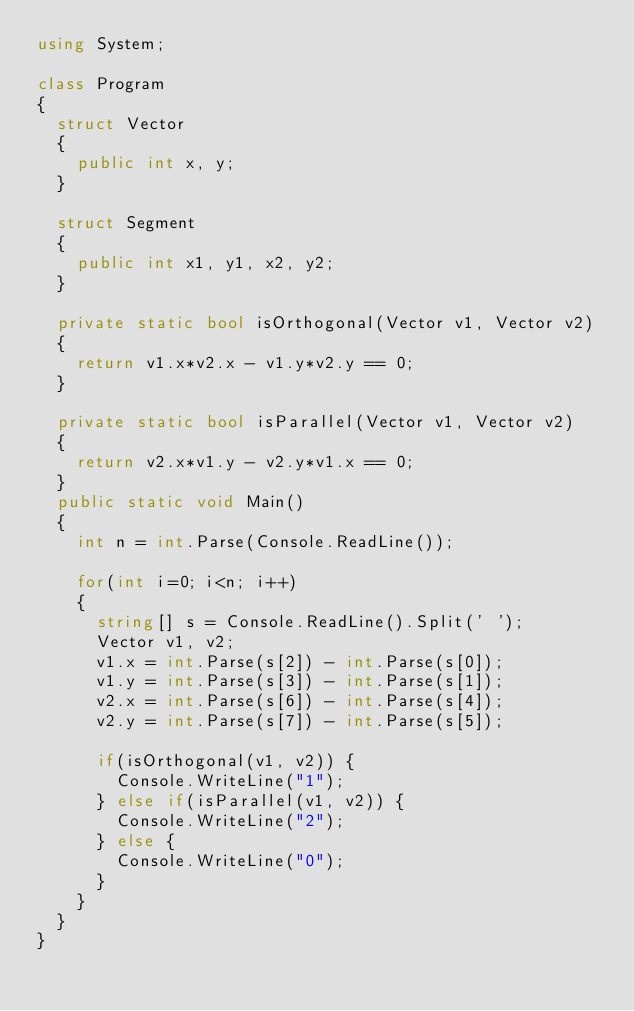<code> <loc_0><loc_0><loc_500><loc_500><_C#_>using System;

class Program
{
  struct Vector
  {
    public int x, y;
  }

  struct Segment
  {
    public int x1, y1, x2, y2;
  }

  private static bool isOrthogonal(Vector v1, Vector v2)
  {
    return v1.x*v2.x - v1.y*v2.y == 0;
  }

  private static bool isParallel(Vector v1, Vector v2)
  {
    return v2.x*v1.y - v2.y*v1.x == 0;
  }
  public static void Main()
  {
    int n = int.Parse(Console.ReadLine());

    for(int i=0; i<n; i++)
    {
      string[] s = Console.ReadLine().Split(' ');
      Vector v1, v2;
      v1.x = int.Parse(s[2]) - int.Parse(s[0]);
      v1.y = int.Parse(s[3]) - int.Parse(s[1]);
      v2.x = int.Parse(s[6]) - int.Parse(s[4]);
      v2.y = int.Parse(s[7]) - int.Parse(s[5]);

      if(isOrthogonal(v1, v2)) {
        Console.WriteLine("1");
      } else if(isParallel(v1, v2)) {
        Console.WriteLine("2");
      } else {
        Console.WriteLine("0");
      }
    }
  }
}</code> 